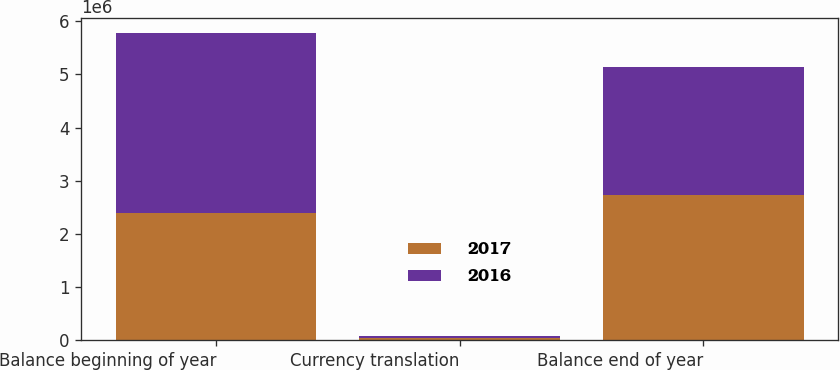Convert chart to OTSL. <chart><loc_0><loc_0><loc_500><loc_500><stacked_bar_chart><ecel><fcel>Balance beginning of year<fcel>Currency translation<fcel>Balance end of year<nl><fcel>2017<fcel>2.39691e+06<fcel>46565<fcel>2.73767e+06<nl><fcel>2016<fcel>3.375e+06<fcel>37394<fcel>2.39691e+06<nl></chart> 